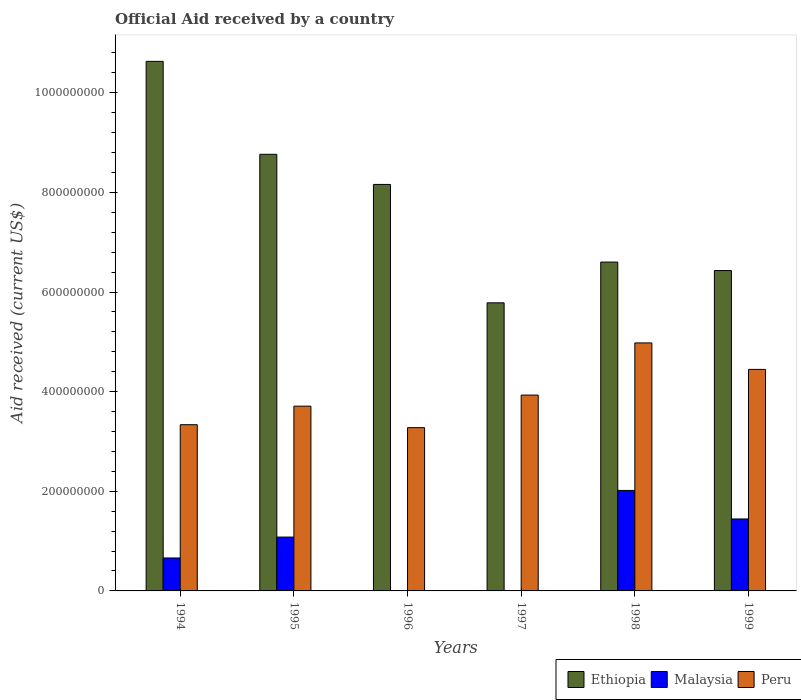How many groups of bars are there?
Your answer should be very brief. 6. How many bars are there on the 3rd tick from the left?
Your response must be concise. 2. What is the net official aid received in Ethiopia in 1995?
Your response must be concise. 8.76e+08. Across all years, what is the maximum net official aid received in Ethiopia?
Give a very brief answer. 1.06e+09. Across all years, what is the minimum net official aid received in Malaysia?
Offer a very short reply. 0. What is the total net official aid received in Malaysia in the graph?
Offer a terse response. 5.20e+08. What is the difference between the net official aid received in Peru in 1996 and that in 1998?
Keep it short and to the point. -1.70e+08. What is the difference between the net official aid received in Malaysia in 1999 and the net official aid received in Ethiopia in 1994?
Ensure brevity in your answer.  -9.19e+08. What is the average net official aid received in Ethiopia per year?
Make the answer very short. 7.73e+08. In the year 1998, what is the difference between the net official aid received in Peru and net official aid received in Ethiopia?
Make the answer very short. -1.62e+08. In how many years, is the net official aid received in Malaysia greater than 680000000 US$?
Make the answer very short. 0. What is the ratio of the net official aid received in Ethiopia in 1994 to that in 1999?
Give a very brief answer. 1.65. Is the difference between the net official aid received in Peru in 1994 and 1998 greater than the difference between the net official aid received in Ethiopia in 1994 and 1998?
Your response must be concise. No. What is the difference between the highest and the second highest net official aid received in Ethiopia?
Ensure brevity in your answer.  1.87e+08. What is the difference between the highest and the lowest net official aid received in Peru?
Your response must be concise. 1.70e+08. Is the sum of the net official aid received in Ethiopia in 1994 and 1999 greater than the maximum net official aid received in Peru across all years?
Your answer should be very brief. Yes. Is it the case that in every year, the sum of the net official aid received in Ethiopia and net official aid received in Malaysia is greater than the net official aid received in Peru?
Ensure brevity in your answer.  Yes. How many bars are there?
Offer a very short reply. 16. Are all the bars in the graph horizontal?
Your response must be concise. No. What is the difference between two consecutive major ticks on the Y-axis?
Make the answer very short. 2.00e+08. Are the values on the major ticks of Y-axis written in scientific E-notation?
Offer a very short reply. No. Does the graph contain any zero values?
Offer a very short reply. Yes. Where does the legend appear in the graph?
Make the answer very short. Bottom right. How are the legend labels stacked?
Keep it short and to the point. Horizontal. What is the title of the graph?
Give a very brief answer. Official Aid received by a country. Does "Antigua and Barbuda" appear as one of the legend labels in the graph?
Your response must be concise. No. What is the label or title of the Y-axis?
Your answer should be compact. Aid received (current US$). What is the Aid received (current US$) of Ethiopia in 1994?
Provide a succinct answer. 1.06e+09. What is the Aid received (current US$) of Malaysia in 1994?
Your answer should be very brief. 6.61e+07. What is the Aid received (current US$) in Peru in 1994?
Offer a very short reply. 3.34e+08. What is the Aid received (current US$) of Ethiopia in 1995?
Your answer should be very brief. 8.76e+08. What is the Aid received (current US$) in Malaysia in 1995?
Your response must be concise. 1.08e+08. What is the Aid received (current US$) of Peru in 1995?
Your answer should be very brief. 3.71e+08. What is the Aid received (current US$) of Ethiopia in 1996?
Provide a short and direct response. 8.16e+08. What is the Aid received (current US$) of Peru in 1996?
Make the answer very short. 3.28e+08. What is the Aid received (current US$) of Ethiopia in 1997?
Your answer should be compact. 5.78e+08. What is the Aid received (current US$) of Peru in 1997?
Your answer should be very brief. 3.93e+08. What is the Aid received (current US$) in Ethiopia in 1998?
Provide a short and direct response. 6.60e+08. What is the Aid received (current US$) of Malaysia in 1998?
Provide a short and direct response. 2.02e+08. What is the Aid received (current US$) of Peru in 1998?
Make the answer very short. 4.98e+08. What is the Aid received (current US$) of Ethiopia in 1999?
Make the answer very short. 6.43e+08. What is the Aid received (current US$) of Malaysia in 1999?
Offer a very short reply. 1.44e+08. What is the Aid received (current US$) of Peru in 1999?
Give a very brief answer. 4.45e+08. Across all years, what is the maximum Aid received (current US$) in Ethiopia?
Your answer should be very brief. 1.06e+09. Across all years, what is the maximum Aid received (current US$) of Malaysia?
Offer a very short reply. 2.02e+08. Across all years, what is the maximum Aid received (current US$) in Peru?
Make the answer very short. 4.98e+08. Across all years, what is the minimum Aid received (current US$) of Ethiopia?
Provide a short and direct response. 5.78e+08. Across all years, what is the minimum Aid received (current US$) of Peru?
Your response must be concise. 3.28e+08. What is the total Aid received (current US$) in Ethiopia in the graph?
Offer a terse response. 4.64e+09. What is the total Aid received (current US$) of Malaysia in the graph?
Keep it short and to the point. 5.20e+08. What is the total Aid received (current US$) in Peru in the graph?
Provide a succinct answer. 2.37e+09. What is the difference between the Aid received (current US$) in Ethiopia in 1994 and that in 1995?
Your answer should be very brief. 1.87e+08. What is the difference between the Aid received (current US$) in Malaysia in 1994 and that in 1995?
Offer a terse response. -4.20e+07. What is the difference between the Aid received (current US$) in Peru in 1994 and that in 1995?
Your answer should be compact. -3.72e+07. What is the difference between the Aid received (current US$) of Ethiopia in 1994 and that in 1996?
Your response must be concise. 2.47e+08. What is the difference between the Aid received (current US$) in Peru in 1994 and that in 1996?
Your answer should be compact. 5.97e+06. What is the difference between the Aid received (current US$) in Ethiopia in 1994 and that in 1997?
Provide a short and direct response. 4.85e+08. What is the difference between the Aid received (current US$) in Peru in 1994 and that in 1997?
Provide a short and direct response. -5.95e+07. What is the difference between the Aid received (current US$) in Ethiopia in 1994 and that in 1998?
Offer a very short reply. 4.03e+08. What is the difference between the Aid received (current US$) of Malaysia in 1994 and that in 1998?
Your answer should be compact. -1.36e+08. What is the difference between the Aid received (current US$) of Peru in 1994 and that in 1998?
Give a very brief answer. -1.64e+08. What is the difference between the Aid received (current US$) of Ethiopia in 1994 and that in 1999?
Your answer should be very brief. 4.20e+08. What is the difference between the Aid received (current US$) in Malaysia in 1994 and that in 1999?
Provide a short and direct response. -7.83e+07. What is the difference between the Aid received (current US$) in Peru in 1994 and that in 1999?
Offer a very short reply. -1.11e+08. What is the difference between the Aid received (current US$) of Ethiopia in 1995 and that in 1996?
Provide a succinct answer. 6.05e+07. What is the difference between the Aid received (current US$) in Peru in 1995 and that in 1996?
Offer a very short reply. 4.32e+07. What is the difference between the Aid received (current US$) of Ethiopia in 1995 and that in 1997?
Keep it short and to the point. 2.98e+08. What is the difference between the Aid received (current US$) in Peru in 1995 and that in 1997?
Your answer should be very brief. -2.22e+07. What is the difference between the Aid received (current US$) of Ethiopia in 1995 and that in 1998?
Provide a succinct answer. 2.16e+08. What is the difference between the Aid received (current US$) in Malaysia in 1995 and that in 1998?
Your answer should be very brief. -9.36e+07. What is the difference between the Aid received (current US$) in Peru in 1995 and that in 1998?
Make the answer very short. -1.27e+08. What is the difference between the Aid received (current US$) in Ethiopia in 1995 and that in 1999?
Give a very brief answer. 2.33e+08. What is the difference between the Aid received (current US$) in Malaysia in 1995 and that in 1999?
Make the answer very short. -3.64e+07. What is the difference between the Aid received (current US$) of Peru in 1995 and that in 1999?
Give a very brief answer. -7.38e+07. What is the difference between the Aid received (current US$) of Ethiopia in 1996 and that in 1997?
Your response must be concise. 2.38e+08. What is the difference between the Aid received (current US$) in Peru in 1996 and that in 1997?
Offer a terse response. -6.54e+07. What is the difference between the Aid received (current US$) in Ethiopia in 1996 and that in 1998?
Your response must be concise. 1.56e+08. What is the difference between the Aid received (current US$) in Peru in 1996 and that in 1998?
Your answer should be compact. -1.70e+08. What is the difference between the Aid received (current US$) of Ethiopia in 1996 and that in 1999?
Offer a very short reply. 1.73e+08. What is the difference between the Aid received (current US$) of Peru in 1996 and that in 1999?
Make the answer very short. -1.17e+08. What is the difference between the Aid received (current US$) of Ethiopia in 1997 and that in 1998?
Give a very brief answer. -8.18e+07. What is the difference between the Aid received (current US$) of Peru in 1997 and that in 1998?
Your answer should be very brief. -1.05e+08. What is the difference between the Aid received (current US$) in Ethiopia in 1997 and that in 1999?
Keep it short and to the point. -6.48e+07. What is the difference between the Aid received (current US$) in Peru in 1997 and that in 1999?
Make the answer very short. -5.15e+07. What is the difference between the Aid received (current US$) of Ethiopia in 1998 and that in 1999?
Keep it short and to the point. 1.71e+07. What is the difference between the Aid received (current US$) of Malaysia in 1998 and that in 1999?
Give a very brief answer. 5.73e+07. What is the difference between the Aid received (current US$) of Peru in 1998 and that in 1999?
Provide a short and direct response. 5.32e+07. What is the difference between the Aid received (current US$) in Ethiopia in 1994 and the Aid received (current US$) in Malaysia in 1995?
Your response must be concise. 9.55e+08. What is the difference between the Aid received (current US$) of Ethiopia in 1994 and the Aid received (current US$) of Peru in 1995?
Offer a terse response. 6.92e+08. What is the difference between the Aid received (current US$) in Malaysia in 1994 and the Aid received (current US$) in Peru in 1995?
Offer a very short reply. -3.05e+08. What is the difference between the Aid received (current US$) of Ethiopia in 1994 and the Aid received (current US$) of Peru in 1996?
Provide a succinct answer. 7.35e+08. What is the difference between the Aid received (current US$) in Malaysia in 1994 and the Aid received (current US$) in Peru in 1996?
Provide a short and direct response. -2.62e+08. What is the difference between the Aid received (current US$) of Ethiopia in 1994 and the Aid received (current US$) of Peru in 1997?
Offer a very short reply. 6.70e+08. What is the difference between the Aid received (current US$) of Malaysia in 1994 and the Aid received (current US$) of Peru in 1997?
Ensure brevity in your answer.  -3.27e+08. What is the difference between the Aid received (current US$) of Ethiopia in 1994 and the Aid received (current US$) of Malaysia in 1998?
Make the answer very short. 8.61e+08. What is the difference between the Aid received (current US$) of Ethiopia in 1994 and the Aid received (current US$) of Peru in 1998?
Your answer should be compact. 5.65e+08. What is the difference between the Aid received (current US$) in Malaysia in 1994 and the Aid received (current US$) in Peru in 1998?
Your answer should be compact. -4.32e+08. What is the difference between the Aid received (current US$) in Ethiopia in 1994 and the Aid received (current US$) in Malaysia in 1999?
Your answer should be very brief. 9.19e+08. What is the difference between the Aid received (current US$) of Ethiopia in 1994 and the Aid received (current US$) of Peru in 1999?
Offer a terse response. 6.18e+08. What is the difference between the Aid received (current US$) in Malaysia in 1994 and the Aid received (current US$) in Peru in 1999?
Your response must be concise. -3.79e+08. What is the difference between the Aid received (current US$) of Ethiopia in 1995 and the Aid received (current US$) of Peru in 1996?
Make the answer very short. 5.49e+08. What is the difference between the Aid received (current US$) in Malaysia in 1995 and the Aid received (current US$) in Peru in 1996?
Offer a very short reply. -2.20e+08. What is the difference between the Aid received (current US$) of Ethiopia in 1995 and the Aid received (current US$) of Peru in 1997?
Offer a very short reply. 4.83e+08. What is the difference between the Aid received (current US$) in Malaysia in 1995 and the Aid received (current US$) in Peru in 1997?
Your answer should be compact. -2.85e+08. What is the difference between the Aid received (current US$) in Ethiopia in 1995 and the Aid received (current US$) in Malaysia in 1998?
Make the answer very short. 6.75e+08. What is the difference between the Aid received (current US$) in Ethiopia in 1995 and the Aid received (current US$) in Peru in 1998?
Offer a very short reply. 3.79e+08. What is the difference between the Aid received (current US$) of Malaysia in 1995 and the Aid received (current US$) of Peru in 1998?
Keep it short and to the point. -3.90e+08. What is the difference between the Aid received (current US$) in Ethiopia in 1995 and the Aid received (current US$) in Malaysia in 1999?
Offer a terse response. 7.32e+08. What is the difference between the Aid received (current US$) in Ethiopia in 1995 and the Aid received (current US$) in Peru in 1999?
Make the answer very short. 4.32e+08. What is the difference between the Aid received (current US$) of Malaysia in 1995 and the Aid received (current US$) of Peru in 1999?
Your answer should be very brief. -3.37e+08. What is the difference between the Aid received (current US$) in Ethiopia in 1996 and the Aid received (current US$) in Peru in 1997?
Ensure brevity in your answer.  4.23e+08. What is the difference between the Aid received (current US$) of Ethiopia in 1996 and the Aid received (current US$) of Malaysia in 1998?
Make the answer very short. 6.14e+08. What is the difference between the Aid received (current US$) of Ethiopia in 1996 and the Aid received (current US$) of Peru in 1998?
Give a very brief answer. 3.18e+08. What is the difference between the Aid received (current US$) in Ethiopia in 1996 and the Aid received (current US$) in Malaysia in 1999?
Your answer should be very brief. 6.72e+08. What is the difference between the Aid received (current US$) in Ethiopia in 1996 and the Aid received (current US$) in Peru in 1999?
Provide a succinct answer. 3.71e+08. What is the difference between the Aid received (current US$) in Ethiopia in 1997 and the Aid received (current US$) in Malaysia in 1998?
Provide a succinct answer. 3.77e+08. What is the difference between the Aid received (current US$) of Ethiopia in 1997 and the Aid received (current US$) of Peru in 1998?
Provide a succinct answer. 8.05e+07. What is the difference between the Aid received (current US$) in Ethiopia in 1997 and the Aid received (current US$) in Malaysia in 1999?
Offer a very short reply. 4.34e+08. What is the difference between the Aid received (current US$) in Ethiopia in 1997 and the Aid received (current US$) in Peru in 1999?
Provide a short and direct response. 1.34e+08. What is the difference between the Aid received (current US$) in Ethiopia in 1998 and the Aid received (current US$) in Malaysia in 1999?
Offer a terse response. 5.16e+08. What is the difference between the Aid received (current US$) in Ethiopia in 1998 and the Aid received (current US$) in Peru in 1999?
Offer a very short reply. 2.15e+08. What is the difference between the Aid received (current US$) in Malaysia in 1998 and the Aid received (current US$) in Peru in 1999?
Ensure brevity in your answer.  -2.43e+08. What is the average Aid received (current US$) of Ethiopia per year?
Ensure brevity in your answer.  7.73e+08. What is the average Aid received (current US$) in Malaysia per year?
Give a very brief answer. 8.67e+07. What is the average Aid received (current US$) of Peru per year?
Offer a terse response. 3.95e+08. In the year 1994, what is the difference between the Aid received (current US$) in Ethiopia and Aid received (current US$) in Malaysia?
Your answer should be compact. 9.97e+08. In the year 1994, what is the difference between the Aid received (current US$) of Ethiopia and Aid received (current US$) of Peru?
Keep it short and to the point. 7.29e+08. In the year 1994, what is the difference between the Aid received (current US$) in Malaysia and Aid received (current US$) in Peru?
Your answer should be very brief. -2.68e+08. In the year 1995, what is the difference between the Aid received (current US$) in Ethiopia and Aid received (current US$) in Malaysia?
Ensure brevity in your answer.  7.68e+08. In the year 1995, what is the difference between the Aid received (current US$) of Ethiopia and Aid received (current US$) of Peru?
Provide a short and direct response. 5.06e+08. In the year 1995, what is the difference between the Aid received (current US$) in Malaysia and Aid received (current US$) in Peru?
Ensure brevity in your answer.  -2.63e+08. In the year 1996, what is the difference between the Aid received (current US$) of Ethiopia and Aid received (current US$) of Peru?
Your response must be concise. 4.88e+08. In the year 1997, what is the difference between the Aid received (current US$) in Ethiopia and Aid received (current US$) in Peru?
Keep it short and to the point. 1.85e+08. In the year 1998, what is the difference between the Aid received (current US$) of Ethiopia and Aid received (current US$) of Malaysia?
Make the answer very short. 4.58e+08. In the year 1998, what is the difference between the Aid received (current US$) in Ethiopia and Aid received (current US$) in Peru?
Make the answer very short. 1.62e+08. In the year 1998, what is the difference between the Aid received (current US$) of Malaysia and Aid received (current US$) of Peru?
Your answer should be compact. -2.96e+08. In the year 1999, what is the difference between the Aid received (current US$) in Ethiopia and Aid received (current US$) in Malaysia?
Your response must be concise. 4.99e+08. In the year 1999, what is the difference between the Aid received (current US$) in Ethiopia and Aid received (current US$) in Peru?
Provide a short and direct response. 1.98e+08. In the year 1999, what is the difference between the Aid received (current US$) in Malaysia and Aid received (current US$) in Peru?
Provide a succinct answer. -3.00e+08. What is the ratio of the Aid received (current US$) in Ethiopia in 1994 to that in 1995?
Provide a succinct answer. 1.21. What is the ratio of the Aid received (current US$) in Malaysia in 1994 to that in 1995?
Your answer should be very brief. 0.61. What is the ratio of the Aid received (current US$) of Peru in 1994 to that in 1995?
Your response must be concise. 0.9. What is the ratio of the Aid received (current US$) of Ethiopia in 1994 to that in 1996?
Your answer should be very brief. 1.3. What is the ratio of the Aid received (current US$) in Peru in 1994 to that in 1996?
Your response must be concise. 1.02. What is the ratio of the Aid received (current US$) in Ethiopia in 1994 to that in 1997?
Your response must be concise. 1.84. What is the ratio of the Aid received (current US$) of Peru in 1994 to that in 1997?
Provide a short and direct response. 0.85. What is the ratio of the Aid received (current US$) in Ethiopia in 1994 to that in 1998?
Offer a very short reply. 1.61. What is the ratio of the Aid received (current US$) in Malaysia in 1994 to that in 1998?
Provide a short and direct response. 0.33. What is the ratio of the Aid received (current US$) of Peru in 1994 to that in 1998?
Provide a succinct answer. 0.67. What is the ratio of the Aid received (current US$) in Ethiopia in 1994 to that in 1999?
Provide a short and direct response. 1.65. What is the ratio of the Aid received (current US$) in Malaysia in 1994 to that in 1999?
Your answer should be very brief. 0.46. What is the ratio of the Aid received (current US$) of Peru in 1994 to that in 1999?
Keep it short and to the point. 0.75. What is the ratio of the Aid received (current US$) of Ethiopia in 1995 to that in 1996?
Ensure brevity in your answer.  1.07. What is the ratio of the Aid received (current US$) in Peru in 1995 to that in 1996?
Your answer should be very brief. 1.13. What is the ratio of the Aid received (current US$) in Ethiopia in 1995 to that in 1997?
Ensure brevity in your answer.  1.52. What is the ratio of the Aid received (current US$) of Peru in 1995 to that in 1997?
Your answer should be very brief. 0.94. What is the ratio of the Aid received (current US$) of Ethiopia in 1995 to that in 1998?
Your answer should be very brief. 1.33. What is the ratio of the Aid received (current US$) of Malaysia in 1995 to that in 1998?
Keep it short and to the point. 0.54. What is the ratio of the Aid received (current US$) in Peru in 1995 to that in 1998?
Make the answer very short. 0.75. What is the ratio of the Aid received (current US$) of Ethiopia in 1995 to that in 1999?
Your answer should be compact. 1.36. What is the ratio of the Aid received (current US$) in Malaysia in 1995 to that in 1999?
Provide a short and direct response. 0.75. What is the ratio of the Aid received (current US$) of Peru in 1995 to that in 1999?
Ensure brevity in your answer.  0.83. What is the ratio of the Aid received (current US$) of Ethiopia in 1996 to that in 1997?
Keep it short and to the point. 1.41. What is the ratio of the Aid received (current US$) of Peru in 1996 to that in 1997?
Keep it short and to the point. 0.83. What is the ratio of the Aid received (current US$) of Ethiopia in 1996 to that in 1998?
Give a very brief answer. 1.24. What is the ratio of the Aid received (current US$) of Peru in 1996 to that in 1998?
Your answer should be very brief. 0.66. What is the ratio of the Aid received (current US$) in Ethiopia in 1996 to that in 1999?
Keep it short and to the point. 1.27. What is the ratio of the Aid received (current US$) in Peru in 1996 to that in 1999?
Your answer should be very brief. 0.74. What is the ratio of the Aid received (current US$) of Ethiopia in 1997 to that in 1998?
Offer a terse response. 0.88. What is the ratio of the Aid received (current US$) of Peru in 1997 to that in 1998?
Your answer should be compact. 0.79. What is the ratio of the Aid received (current US$) of Ethiopia in 1997 to that in 1999?
Offer a terse response. 0.9. What is the ratio of the Aid received (current US$) in Peru in 1997 to that in 1999?
Provide a succinct answer. 0.88. What is the ratio of the Aid received (current US$) in Ethiopia in 1998 to that in 1999?
Ensure brevity in your answer.  1.03. What is the ratio of the Aid received (current US$) in Malaysia in 1998 to that in 1999?
Give a very brief answer. 1.4. What is the ratio of the Aid received (current US$) in Peru in 1998 to that in 1999?
Your answer should be compact. 1.12. What is the difference between the highest and the second highest Aid received (current US$) of Ethiopia?
Your answer should be very brief. 1.87e+08. What is the difference between the highest and the second highest Aid received (current US$) of Malaysia?
Your answer should be very brief. 5.73e+07. What is the difference between the highest and the second highest Aid received (current US$) of Peru?
Ensure brevity in your answer.  5.32e+07. What is the difference between the highest and the lowest Aid received (current US$) of Ethiopia?
Your answer should be very brief. 4.85e+08. What is the difference between the highest and the lowest Aid received (current US$) of Malaysia?
Keep it short and to the point. 2.02e+08. What is the difference between the highest and the lowest Aid received (current US$) in Peru?
Your answer should be compact. 1.70e+08. 